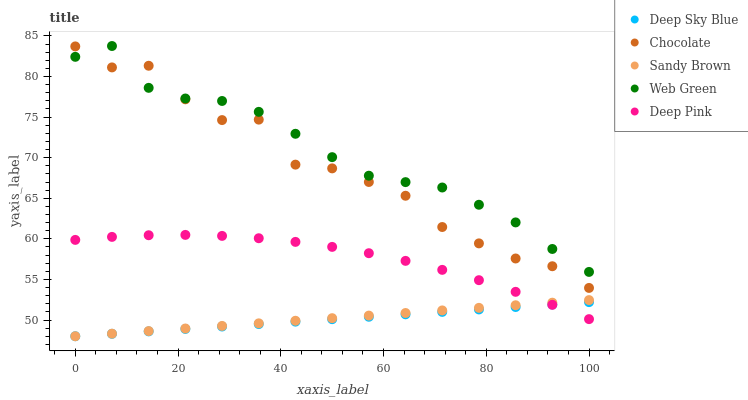Does Deep Sky Blue have the minimum area under the curve?
Answer yes or no. Yes. Does Web Green have the maximum area under the curve?
Answer yes or no. Yes. Does Sandy Brown have the minimum area under the curve?
Answer yes or no. No. Does Sandy Brown have the maximum area under the curve?
Answer yes or no. No. Is Deep Sky Blue the smoothest?
Answer yes or no. Yes. Is Chocolate the roughest?
Answer yes or no. Yes. Is Sandy Brown the smoothest?
Answer yes or no. No. Is Sandy Brown the roughest?
Answer yes or no. No. Does Sandy Brown have the lowest value?
Answer yes or no. Yes. Does Web Green have the lowest value?
Answer yes or no. No. Does Web Green have the highest value?
Answer yes or no. Yes. Does Sandy Brown have the highest value?
Answer yes or no. No. Is Deep Sky Blue less than Web Green?
Answer yes or no. Yes. Is Chocolate greater than Sandy Brown?
Answer yes or no. Yes. Does Sandy Brown intersect Deep Sky Blue?
Answer yes or no. Yes. Is Sandy Brown less than Deep Sky Blue?
Answer yes or no. No. Is Sandy Brown greater than Deep Sky Blue?
Answer yes or no. No. Does Deep Sky Blue intersect Web Green?
Answer yes or no. No. 